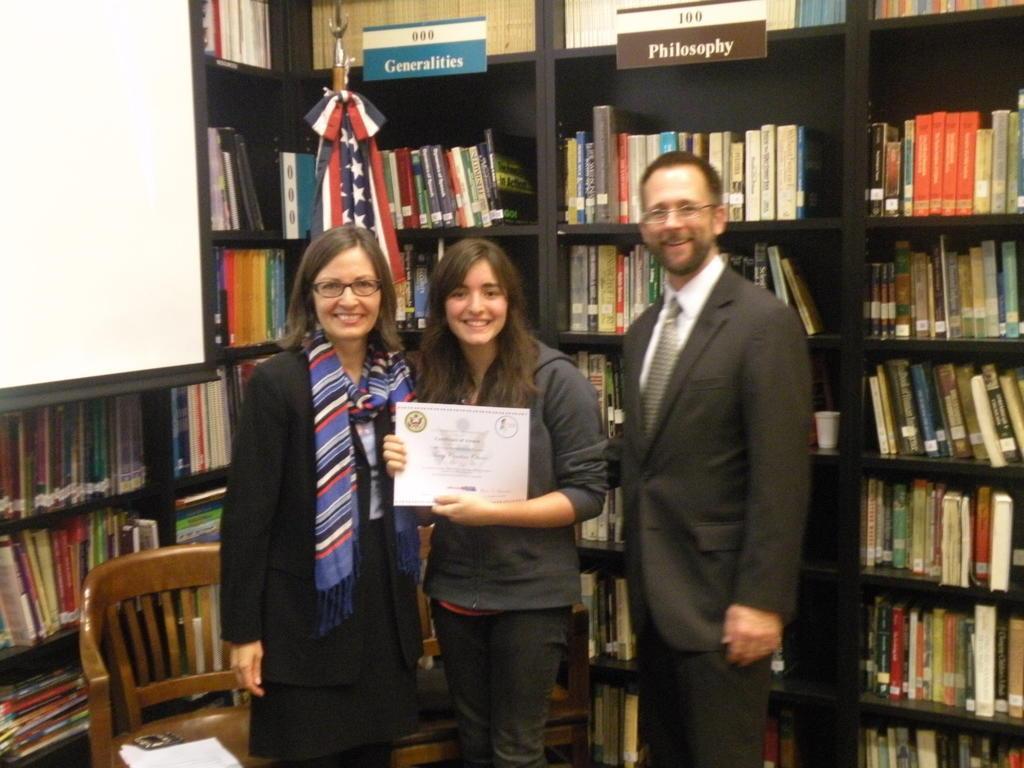Please provide a concise description of this image. It is taken in a closed room where three people are standing behind them there are shelves and number of books are present and there is a flag and there are some text written on the shelfs and at the right corner of the picture there are one screen and empty chair and some papers on it, at the right corner of the picture the man is wearing a suit and in the left corner of the picture the person is wearing a dress and a scarf and in the middle the person is holding a certificate. 